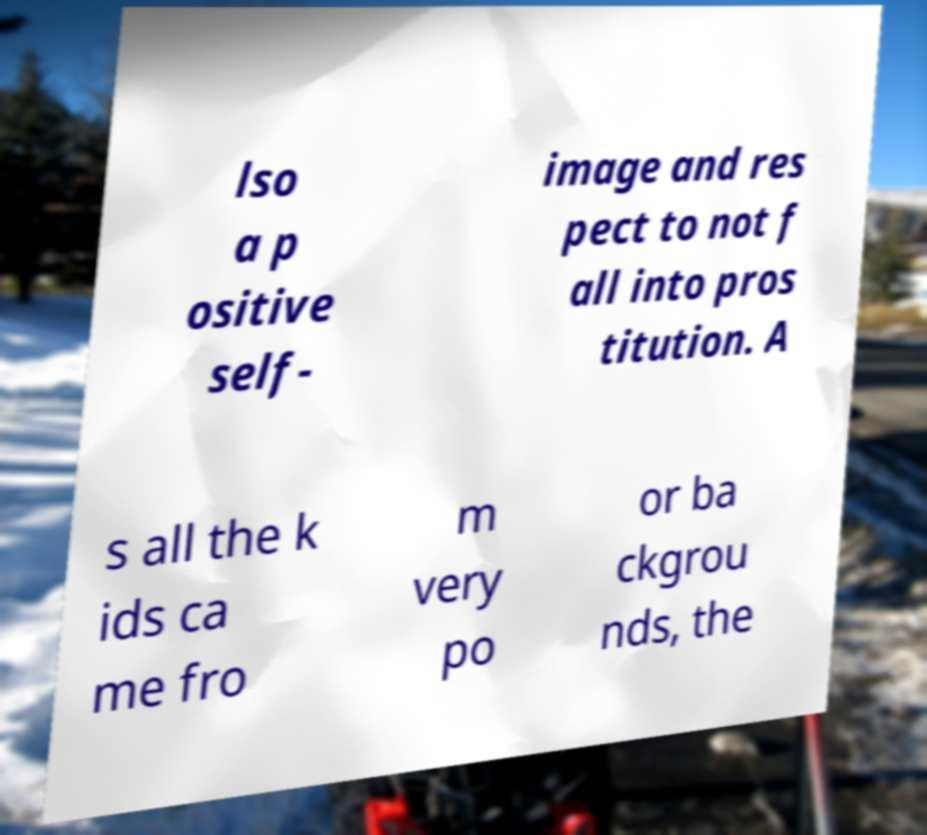Please read and relay the text visible in this image. What does it say? lso a p ositive self- image and res pect to not f all into pros titution. A s all the k ids ca me fro m very po or ba ckgrou nds, the 